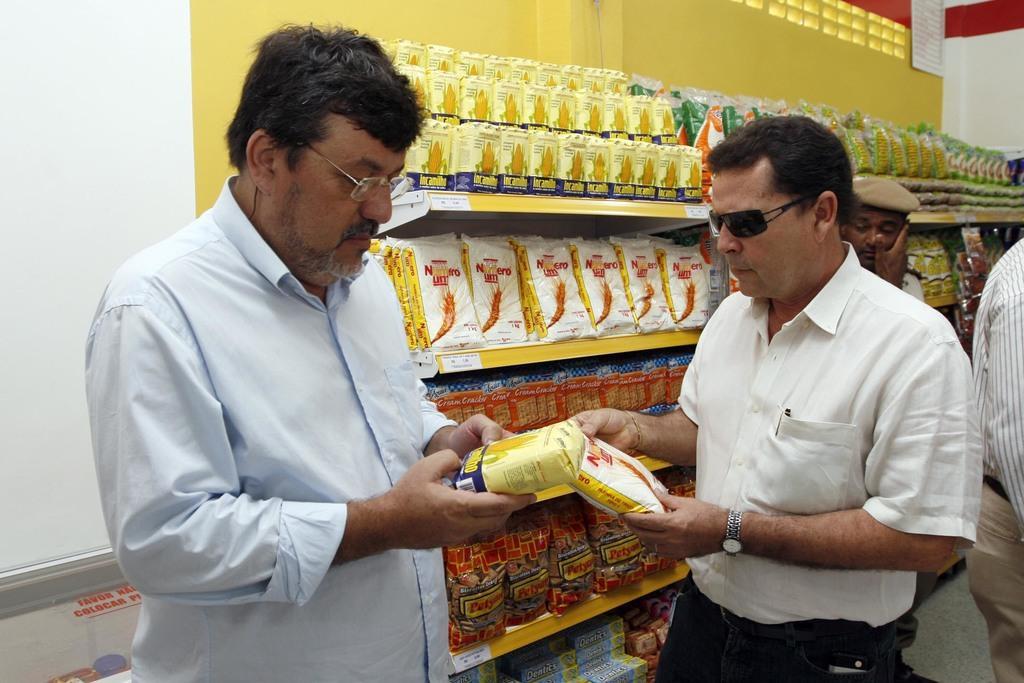In one or two sentences, can you explain what this image depicts? In this image we can see few people standing and few people holding some objects in their hands. We can see the inside of a store. There are many objects placed on the racks. There is an object on the wall at the right top most of the image. There is an object and few objects placed in it at the left bottom most of the image. 